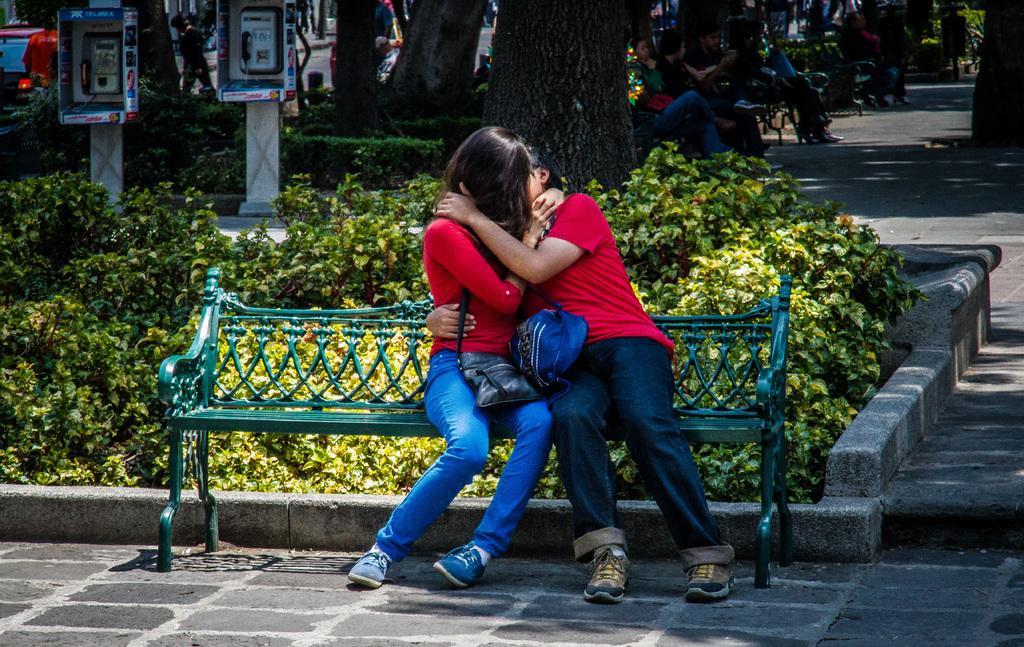In one or two sentences, can you explain what this image depicts? In the center we can see two persons were sitting on the bench. And they were holding handbag. In the background there is a tree,vehicle,plant,road and few persons were sitting on the bench. 